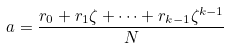<formula> <loc_0><loc_0><loc_500><loc_500>a = \frac { r _ { 0 } + r _ { 1 } \zeta + \cdots + r _ { k - 1 } \zeta ^ { k - 1 } } { N }</formula> 